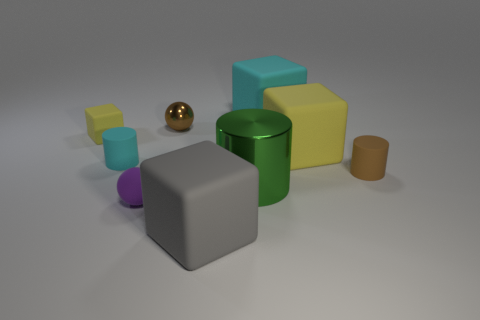Subtract all large shiny cylinders. How many cylinders are left? 2 Subtract all green cylinders. How many yellow blocks are left? 2 Subtract all brown cylinders. How many cylinders are left? 2 Subtract 1 cyan cubes. How many objects are left? 8 Subtract all blocks. How many objects are left? 5 Subtract 1 cubes. How many cubes are left? 3 Subtract all gray cylinders. Subtract all blue cubes. How many cylinders are left? 3 Subtract all cyan matte cylinders. Subtract all brown rubber cylinders. How many objects are left? 7 Add 5 tiny purple rubber objects. How many tiny purple rubber objects are left? 6 Add 6 small spheres. How many small spheres exist? 8 